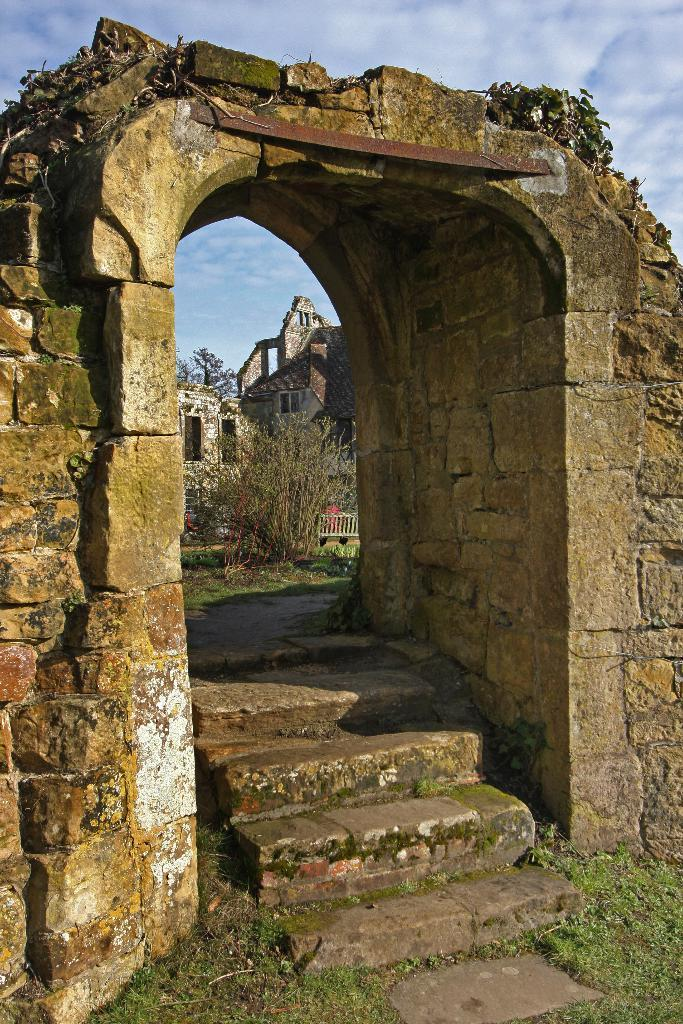What architectural feature is the main subject of the image? There is a stone arch in the image. What is located below the stone arch? There are steps below the stone arch. What can be seen in the background of the image? There is a stone building in the background of the image. What type of vegetation is in front of the stone building? There is a tree in front of the stone building. What is visible in the sky in the image? The sky is visible in the image, and clouds are present. What type of fold can be seen in the image? There is no fold present in the image. What kind of knife is being used by the person in the image? There is no person or knife present in the image. 